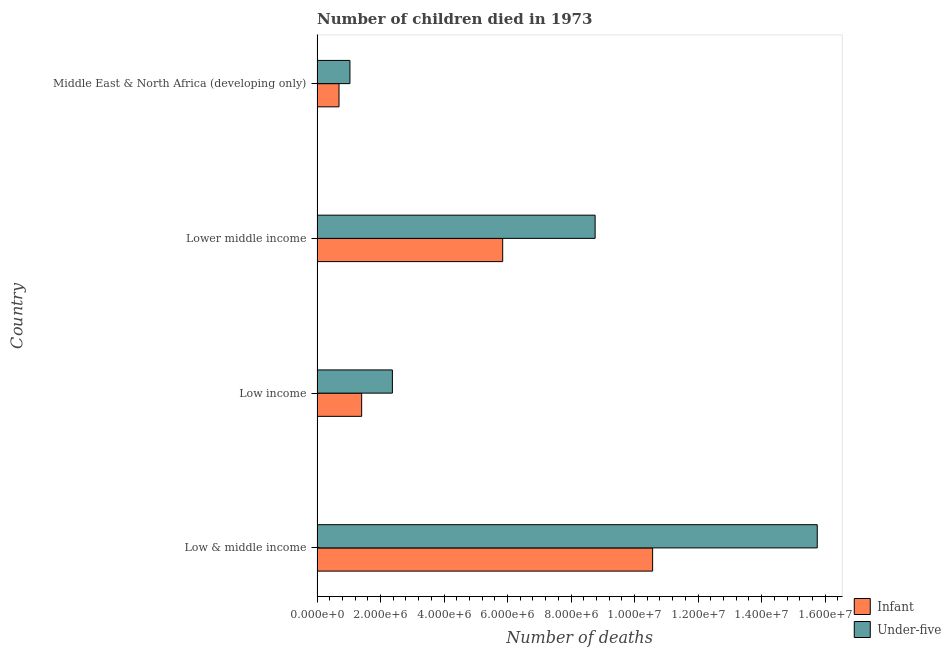How many different coloured bars are there?
Offer a very short reply. 2. How many groups of bars are there?
Make the answer very short. 4. Are the number of bars per tick equal to the number of legend labels?
Your response must be concise. Yes. How many bars are there on the 4th tick from the bottom?
Provide a succinct answer. 2. What is the label of the 1st group of bars from the top?
Provide a succinct answer. Middle East & North Africa (developing only). In how many cases, is the number of bars for a given country not equal to the number of legend labels?
Offer a terse response. 0. What is the number of under-five deaths in Low income?
Give a very brief answer. 2.37e+06. Across all countries, what is the maximum number of infant deaths?
Make the answer very short. 1.06e+07. Across all countries, what is the minimum number of under-five deaths?
Provide a succinct answer. 1.04e+06. In which country was the number of under-five deaths maximum?
Ensure brevity in your answer.  Low & middle income. In which country was the number of infant deaths minimum?
Provide a short and direct response. Middle East & North Africa (developing only). What is the total number of under-five deaths in the graph?
Your response must be concise. 2.79e+07. What is the difference between the number of infant deaths in Low & middle income and that in Lower middle income?
Your answer should be compact. 4.72e+06. What is the difference between the number of under-five deaths in Low & middle income and the number of infant deaths in Low income?
Make the answer very short. 1.43e+07. What is the average number of infant deaths per country?
Your answer should be compact. 4.63e+06. What is the difference between the number of under-five deaths and number of infant deaths in Low & middle income?
Keep it short and to the point. 5.18e+06. In how many countries, is the number of infant deaths greater than 14000000 ?
Give a very brief answer. 0. What is the ratio of the number of under-five deaths in Low income to that in Middle East & North Africa (developing only)?
Offer a very short reply. 2.29. Is the difference between the number of infant deaths in Lower middle income and Middle East & North Africa (developing only) greater than the difference between the number of under-five deaths in Lower middle income and Middle East & North Africa (developing only)?
Ensure brevity in your answer.  No. What is the difference between the highest and the second highest number of infant deaths?
Offer a very short reply. 4.72e+06. What is the difference between the highest and the lowest number of infant deaths?
Your response must be concise. 9.88e+06. What does the 2nd bar from the top in Low income represents?
Give a very brief answer. Infant. What does the 2nd bar from the bottom in Lower middle income represents?
Your answer should be very brief. Under-five. What is the difference between two consecutive major ticks on the X-axis?
Provide a short and direct response. 2.00e+06. Are the values on the major ticks of X-axis written in scientific E-notation?
Make the answer very short. Yes. Does the graph contain grids?
Offer a very short reply. No. Where does the legend appear in the graph?
Make the answer very short. Bottom right. How are the legend labels stacked?
Your response must be concise. Vertical. What is the title of the graph?
Make the answer very short. Number of children died in 1973. Does "Money lenders" appear as one of the legend labels in the graph?
Offer a very short reply. No. What is the label or title of the X-axis?
Offer a terse response. Number of deaths. What is the Number of deaths of Infant in Low & middle income?
Give a very brief answer. 1.06e+07. What is the Number of deaths of Under-five in Low & middle income?
Make the answer very short. 1.58e+07. What is the Number of deaths in Infant in Low income?
Your answer should be compact. 1.40e+06. What is the Number of deaths in Under-five in Low income?
Provide a short and direct response. 2.37e+06. What is the Number of deaths of Infant in Lower middle income?
Your response must be concise. 5.85e+06. What is the Number of deaths in Under-five in Lower middle income?
Ensure brevity in your answer.  8.76e+06. What is the Number of deaths in Infant in Middle East & North Africa (developing only)?
Your response must be concise. 6.92e+05. What is the Number of deaths in Under-five in Middle East & North Africa (developing only)?
Provide a short and direct response. 1.04e+06. Across all countries, what is the maximum Number of deaths in Infant?
Keep it short and to the point. 1.06e+07. Across all countries, what is the maximum Number of deaths in Under-five?
Offer a terse response. 1.58e+07. Across all countries, what is the minimum Number of deaths of Infant?
Your answer should be very brief. 6.92e+05. Across all countries, what is the minimum Number of deaths of Under-five?
Give a very brief answer. 1.04e+06. What is the total Number of deaths in Infant in the graph?
Make the answer very short. 1.85e+07. What is the total Number of deaths of Under-five in the graph?
Give a very brief answer. 2.79e+07. What is the difference between the Number of deaths in Infant in Low & middle income and that in Low income?
Your answer should be compact. 9.16e+06. What is the difference between the Number of deaths of Under-five in Low & middle income and that in Low income?
Provide a succinct answer. 1.34e+07. What is the difference between the Number of deaths in Infant in Low & middle income and that in Lower middle income?
Keep it short and to the point. 4.72e+06. What is the difference between the Number of deaths of Under-five in Low & middle income and that in Lower middle income?
Give a very brief answer. 7.00e+06. What is the difference between the Number of deaths of Infant in Low & middle income and that in Middle East & North Africa (developing only)?
Offer a terse response. 9.88e+06. What is the difference between the Number of deaths of Under-five in Low & middle income and that in Middle East & North Africa (developing only)?
Your response must be concise. 1.47e+07. What is the difference between the Number of deaths in Infant in Low income and that in Lower middle income?
Provide a short and direct response. -4.44e+06. What is the difference between the Number of deaths of Under-five in Low income and that in Lower middle income?
Your answer should be very brief. -6.38e+06. What is the difference between the Number of deaths in Infant in Low income and that in Middle East & North Africa (developing only)?
Ensure brevity in your answer.  7.13e+05. What is the difference between the Number of deaths in Under-five in Low income and that in Middle East & North Africa (developing only)?
Your answer should be very brief. 1.34e+06. What is the difference between the Number of deaths in Infant in Lower middle income and that in Middle East & North Africa (developing only)?
Keep it short and to the point. 5.15e+06. What is the difference between the Number of deaths of Under-five in Lower middle income and that in Middle East & North Africa (developing only)?
Your answer should be compact. 7.72e+06. What is the difference between the Number of deaths in Infant in Low & middle income and the Number of deaths in Under-five in Low income?
Offer a very short reply. 8.20e+06. What is the difference between the Number of deaths in Infant in Low & middle income and the Number of deaths in Under-five in Lower middle income?
Offer a very short reply. 1.81e+06. What is the difference between the Number of deaths in Infant in Low & middle income and the Number of deaths in Under-five in Middle East & North Africa (developing only)?
Offer a terse response. 9.53e+06. What is the difference between the Number of deaths of Infant in Low income and the Number of deaths of Under-five in Lower middle income?
Give a very brief answer. -7.35e+06. What is the difference between the Number of deaths in Infant in Low income and the Number of deaths in Under-five in Middle East & North Africa (developing only)?
Provide a succinct answer. 3.69e+05. What is the difference between the Number of deaths in Infant in Lower middle income and the Number of deaths in Under-five in Middle East & North Africa (developing only)?
Keep it short and to the point. 4.81e+06. What is the average Number of deaths in Infant per country?
Provide a short and direct response. 4.63e+06. What is the average Number of deaths of Under-five per country?
Your answer should be compact. 6.98e+06. What is the difference between the Number of deaths of Infant and Number of deaths of Under-five in Low & middle income?
Give a very brief answer. -5.18e+06. What is the difference between the Number of deaths of Infant and Number of deaths of Under-five in Low income?
Make the answer very short. -9.68e+05. What is the difference between the Number of deaths of Infant and Number of deaths of Under-five in Lower middle income?
Give a very brief answer. -2.91e+06. What is the difference between the Number of deaths of Infant and Number of deaths of Under-five in Middle East & North Africa (developing only)?
Your response must be concise. -3.44e+05. What is the ratio of the Number of deaths in Infant in Low & middle income to that in Low income?
Offer a very short reply. 7.52. What is the ratio of the Number of deaths in Under-five in Low & middle income to that in Low income?
Your answer should be compact. 6.64. What is the ratio of the Number of deaths of Infant in Low & middle income to that in Lower middle income?
Your answer should be very brief. 1.81. What is the ratio of the Number of deaths in Under-five in Low & middle income to that in Lower middle income?
Provide a succinct answer. 1.8. What is the ratio of the Number of deaths of Infant in Low & middle income to that in Middle East & North Africa (developing only)?
Ensure brevity in your answer.  15.27. What is the ratio of the Number of deaths in Under-five in Low & middle income to that in Middle East & North Africa (developing only)?
Your answer should be very brief. 15.21. What is the ratio of the Number of deaths in Infant in Low income to that in Lower middle income?
Make the answer very short. 0.24. What is the ratio of the Number of deaths of Under-five in Low income to that in Lower middle income?
Ensure brevity in your answer.  0.27. What is the ratio of the Number of deaths in Infant in Low income to that in Middle East & North Africa (developing only)?
Make the answer very short. 2.03. What is the ratio of the Number of deaths in Under-five in Low income to that in Middle East & North Africa (developing only)?
Offer a terse response. 2.29. What is the ratio of the Number of deaths in Infant in Lower middle income to that in Middle East & North Africa (developing only)?
Your answer should be compact. 8.45. What is the ratio of the Number of deaths in Under-five in Lower middle income to that in Middle East & North Africa (developing only)?
Make the answer very short. 8.45. What is the difference between the highest and the second highest Number of deaths in Infant?
Give a very brief answer. 4.72e+06. What is the difference between the highest and the second highest Number of deaths of Under-five?
Your answer should be very brief. 7.00e+06. What is the difference between the highest and the lowest Number of deaths in Infant?
Keep it short and to the point. 9.88e+06. What is the difference between the highest and the lowest Number of deaths of Under-five?
Provide a succinct answer. 1.47e+07. 